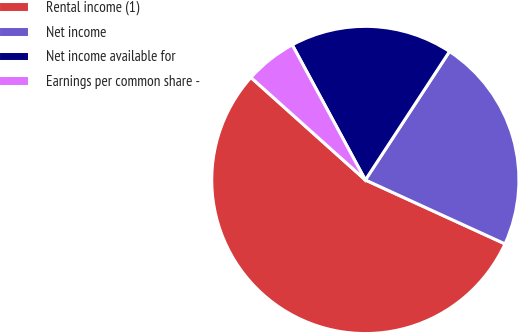Convert chart to OTSL. <chart><loc_0><loc_0><loc_500><loc_500><pie_chart><fcel>Rental income (1)<fcel>Net income<fcel>Net income available for<fcel>Earnings per common share -<nl><fcel>54.79%<fcel>22.6%<fcel>17.12%<fcel>5.48%<nl></chart> 